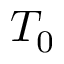<formula> <loc_0><loc_0><loc_500><loc_500>T _ { 0 }</formula> 